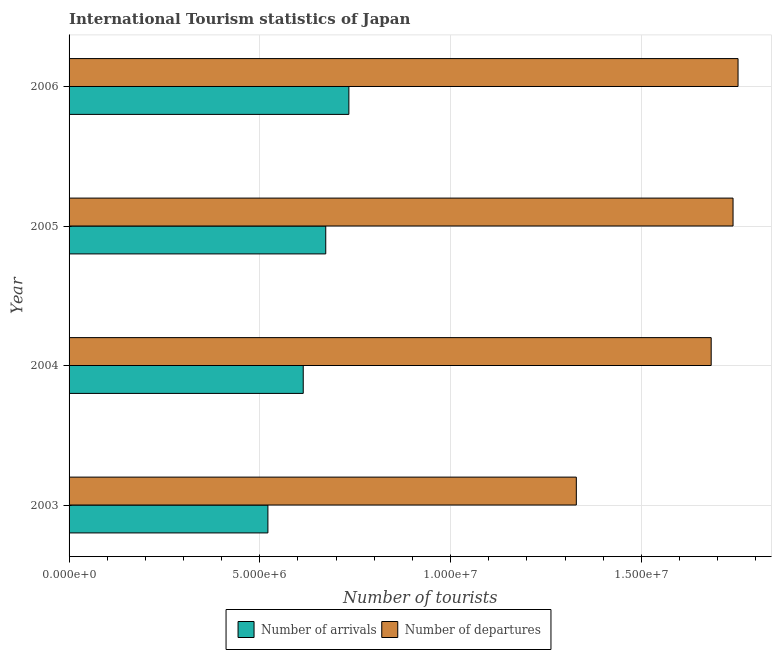How many different coloured bars are there?
Provide a succinct answer. 2. How many groups of bars are there?
Your response must be concise. 4. Are the number of bars per tick equal to the number of legend labels?
Provide a succinct answer. Yes. Are the number of bars on each tick of the Y-axis equal?
Your response must be concise. Yes. How many bars are there on the 2nd tick from the bottom?
Your response must be concise. 2. In how many cases, is the number of bars for a given year not equal to the number of legend labels?
Your response must be concise. 0. What is the number of tourist departures in 2005?
Your answer should be very brief. 1.74e+07. Across all years, what is the maximum number of tourist departures?
Offer a terse response. 1.75e+07. Across all years, what is the minimum number of tourist departures?
Your response must be concise. 1.33e+07. In which year was the number of tourist departures maximum?
Ensure brevity in your answer.  2006. In which year was the number of tourist arrivals minimum?
Provide a succinct answer. 2003. What is the total number of tourist departures in the graph?
Your response must be concise. 6.51e+07. What is the difference between the number of tourist arrivals in 2004 and that in 2006?
Your answer should be very brief. -1.20e+06. What is the difference between the number of tourist departures in 2004 and the number of tourist arrivals in 2003?
Your response must be concise. 1.16e+07. What is the average number of tourist arrivals per year?
Keep it short and to the point. 6.35e+06. In the year 2003, what is the difference between the number of tourist departures and number of tourist arrivals?
Offer a very short reply. 8.08e+06. In how many years, is the number of tourist departures greater than 14000000 ?
Keep it short and to the point. 3. What is the difference between the highest and the second highest number of tourist departures?
Your answer should be very brief. 1.31e+05. What is the difference between the highest and the lowest number of tourist arrivals?
Make the answer very short. 2.12e+06. What does the 1st bar from the top in 2004 represents?
Offer a very short reply. Number of departures. What does the 1st bar from the bottom in 2004 represents?
Offer a very short reply. Number of arrivals. What is the difference between two consecutive major ticks on the X-axis?
Keep it short and to the point. 5.00e+06. Does the graph contain any zero values?
Keep it short and to the point. No. Does the graph contain grids?
Ensure brevity in your answer.  Yes. What is the title of the graph?
Offer a terse response. International Tourism statistics of Japan. What is the label or title of the X-axis?
Offer a terse response. Number of tourists. What is the label or title of the Y-axis?
Your response must be concise. Year. What is the Number of tourists of Number of arrivals in 2003?
Offer a terse response. 5.21e+06. What is the Number of tourists in Number of departures in 2003?
Ensure brevity in your answer.  1.33e+07. What is the Number of tourists of Number of arrivals in 2004?
Ensure brevity in your answer.  6.14e+06. What is the Number of tourists of Number of departures in 2004?
Offer a very short reply. 1.68e+07. What is the Number of tourists of Number of arrivals in 2005?
Ensure brevity in your answer.  6.73e+06. What is the Number of tourists of Number of departures in 2005?
Keep it short and to the point. 1.74e+07. What is the Number of tourists in Number of arrivals in 2006?
Give a very brief answer. 7.33e+06. What is the Number of tourists in Number of departures in 2006?
Offer a very short reply. 1.75e+07. Across all years, what is the maximum Number of tourists in Number of arrivals?
Give a very brief answer. 7.33e+06. Across all years, what is the maximum Number of tourists of Number of departures?
Keep it short and to the point. 1.75e+07. Across all years, what is the minimum Number of tourists of Number of arrivals?
Give a very brief answer. 5.21e+06. Across all years, what is the minimum Number of tourists of Number of departures?
Offer a very short reply. 1.33e+07. What is the total Number of tourists in Number of arrivals in the graph?
Keep it short and to the point. 2.54e+07. What is the total Number of tourists in Number of departures in the graph?
Offer a very short reply. 6.51e+07. What is the difference between the Number of tourists in Number of arrivals in 2003 and that in 2004?
Offer a very short reply. -9.26e+05. What is the difference between the Number of tourists of Number of departures in 2003 and that in 2004?
Give a very brief answer. -3.54e+06. What is the difference between the Number of tourists in Number of arrivals in 2003 and that in 2005?
Your answer should be compact. -1.52e+06. What is the difference between the Number of tourists in Number of departures in 2003 and that in 2005?
Offer a terse response. -4.11e+06. What is the difference between the Number of tourists in Number of arrivals in 2003 and that in 2006?
Your answer should be compact. -2.12e+06. What is the difference between the Number of tourists in Number of departures in 2003 and that in 2006?
Your answer should be compact. -4.24e+06. What is the difference between the Number of tourists in Number of arrivals in 2004 and that in 2005?
Make the answer very short. -5.90e+05. What is the difference between the Number of tourists of Number of departures in 2004 and that in 2005?
Provide a short and direct response. -5.73e+05. What is the difference between the Number of tourists in Number of arrivals in 2004 and that in 2006?
Offer a terse response. -1.20e+06. What is the difference between the Number of tourists of Number of departures in 2004 and that in 2006?
Provide a succinct answer. -7.04e+05. What is the difference between the Number of tourists in Number of arrivals in 2005 and that in 2006?
Offer a terse response. -6.06e+05. What is the difference between the Number of tourists in Number of departures in 2005 and that in 2006?
Ensure brevity in your answer.  -1.31e+05. What is the difference between the Number of tourists of Number of arrivals in 2003 and the Number of tourists of Number of departures in 2004?
Offer a very short reply. -1.16e+07. What is the difference between the Number of tourists in Number of arrivals in 2003 and the Number of tourists in Number of departures in 2005?
Keep it short and to the point. -1.22e+07. What is the difference between the Number of tourists in Number of arrivals in 2003 and the Number of tourists in Number of departures in 2006?
Provide a short and direct response. -1.23e+07. What is the difference between the Number of tourists in Number of arrivals in 2004 and the Number of tourists in Number of departures in 2005?
Offer a very short reply. -1.13e+07. What is the difference between the Number of tourists in Number of arrivals in 2004 and the Number of tourists in Number of departures in 2006?
Give a very brief answer. -1.14e+07. What is the difference between the Number of tourists in Number of arrivals in 2005 and the Number of tourists in Number of departures in 2006?
Offer a terse response. -1.08e+07. What is the average Number of tourists of Number of arrivals per year?
Offer a very short reply. 6.35e+06. What is the average Number of tourists in Number of departures per year?
Your answer should be compact. 1.63e+07. In the year 2003, what is the difference between the Number of tourists of Number of arrivals and Number of tourists of Number of departures?
Ensure brevity in your answer.  -8.08e+06. In the year 2004, what is the difference between the Number of tourists in Number of arrivals and Number of tourists in Number of departures?
Ensure brevity in your answer.  -1.07e+07. In the year 2005, what is the difference between the Number of tourists in Number of arrivals and Number of tourists in Number of departures?
Provide a short and direct response. -1.07e+07. In the year 2006, what is the difference between the Number of tourists in Number of arrivals and Number of tourists in Number of departures?
Offer a very short reply. -1.02e+07. What is the ratio of the Number of tourists of Number of arrivals in 2003 to that in 2004?
Provide a short and direct response. 0.85. What is the ratio of the Number of tourists of Number of departures in 2003 to that in 2004?
Offer a very short reply. 0.79. What is the ratio of the Number of tourists of Number of arrivals in 2003 to that in 2005?
Your answer should be very brief. 0.77. What is the ratio of the Number of tourists in Number of departures in 2003 to that in 2005?
Your answer should be very brief. 0.76. What is the ratio of the Number of tourists of Number of arrivals in 2003 to that in 2006?
Provide a short and direct response. 0.71. What is the ratio of the Number of tourists of Number of departures in 2003 to that in 2006?
Give a very brief answer. 0.76. What is the ratio of the Number of tourists in Number of arrivals in 2004 to that in 2005?
Ensure brevity in your answer.  0.91. What is the ratio of the Number of tourists in Number of departures in 2004 to that in 2005?
Provide a short and direct response. 0.97. What is the ratio of the Number of tourists of Number of arrivals in 2004 to that in 2006?
Offer a terse response. 0.84. What is the ratio of the Number of tourists in Number of departures in 2004 to that in 2006?
Offer a terse response. 0.96. What is the ratio of the Number of tourists of Number of arrivals in 2005 to that in 2006?
Ensure brevity in your answer.  0.92. What is the difference between the highest and the second highest Number of tourists of Number of arrivals?
Your response must be concise. 6.06e+05. What is the difference between the highest and the second highest Number of tourists in Number of departures?
Ensure brevity in your answer.  1.31e+05. What is the difference between the highest and the lowest Number of tourists of Number of arrivals?
Keep it short and to the point. 2.12e+06. What is the difference between the highest and the lowest Number of tourists in Number of departures?
Offer a very short reply. 4.24e+06. 